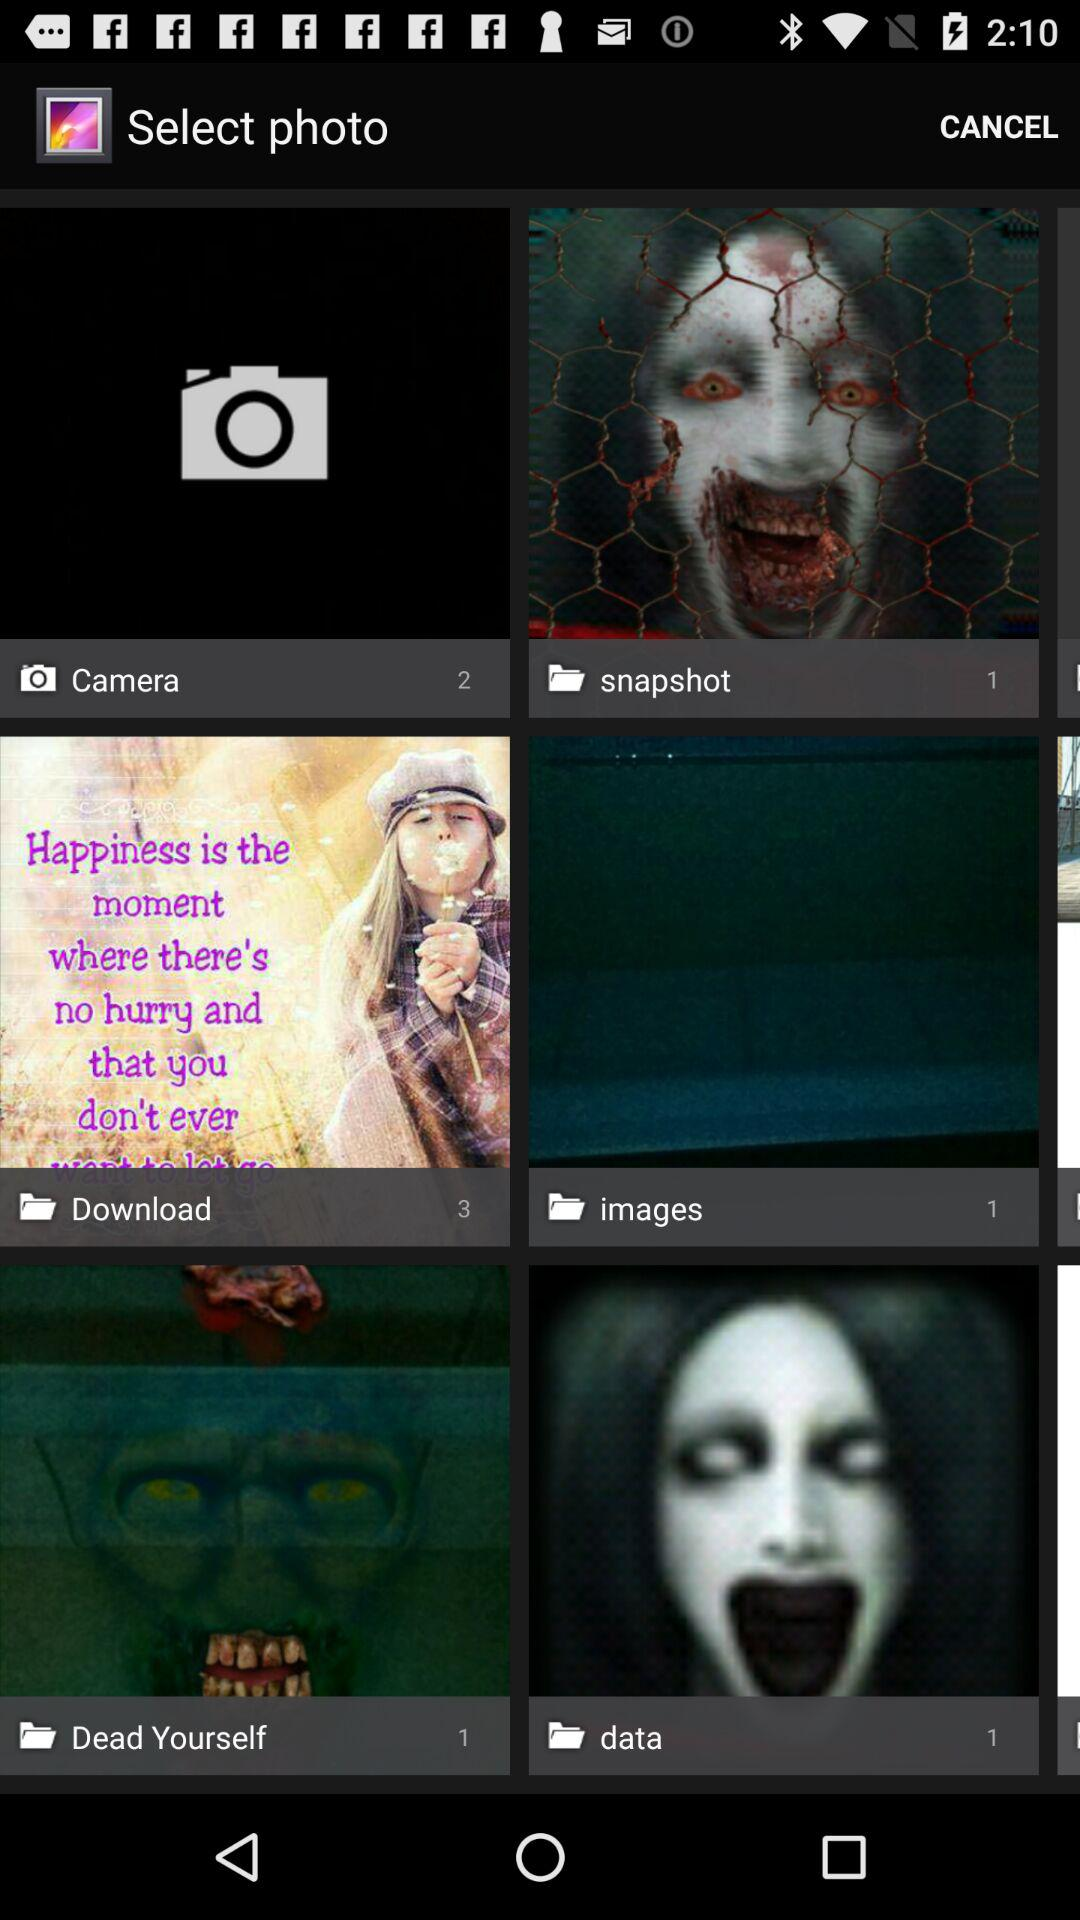How many images are in the "snapshot"? There is 1 image in the "snapshot". 